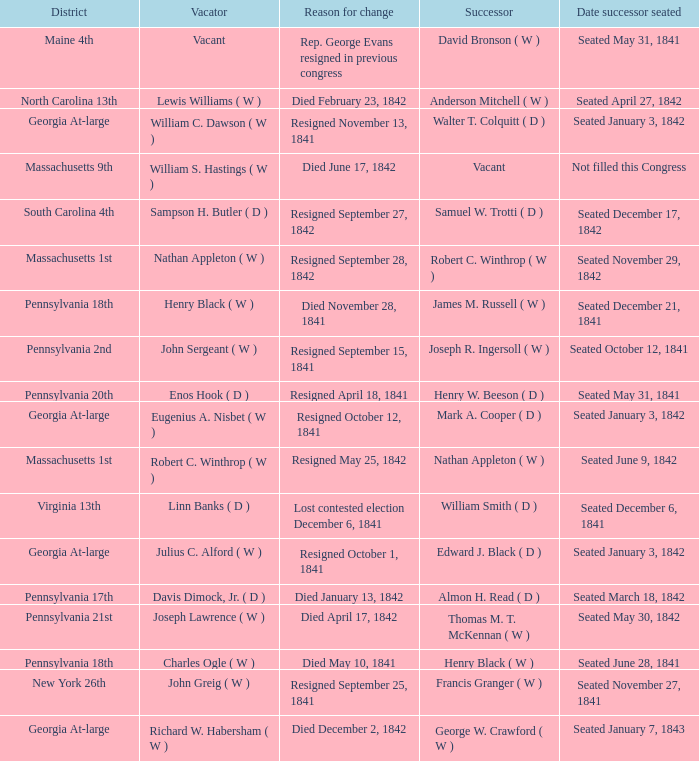Name the successor for north carolina 13th Anderson Mitchell ( W ). 